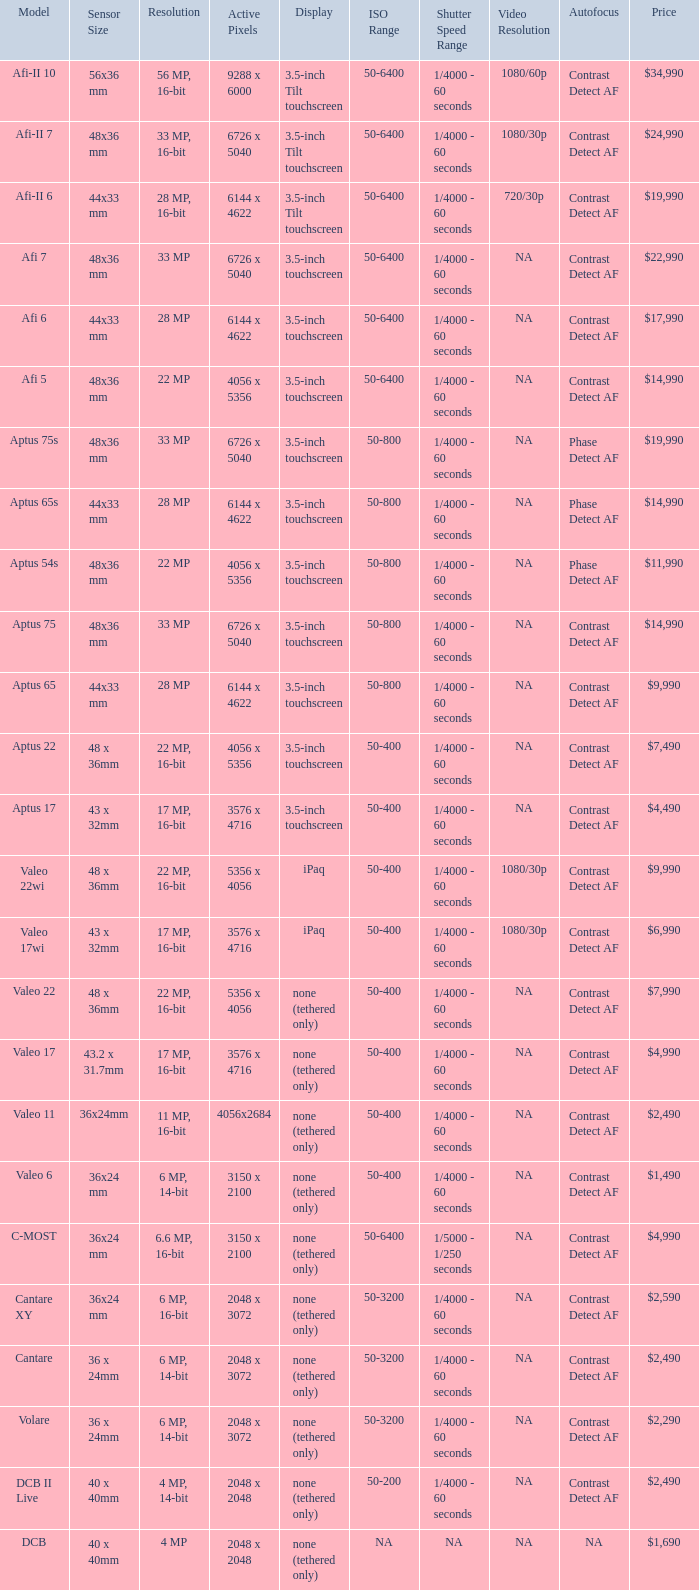What are the active pixels of the cantare model? 2048 x 3072. 